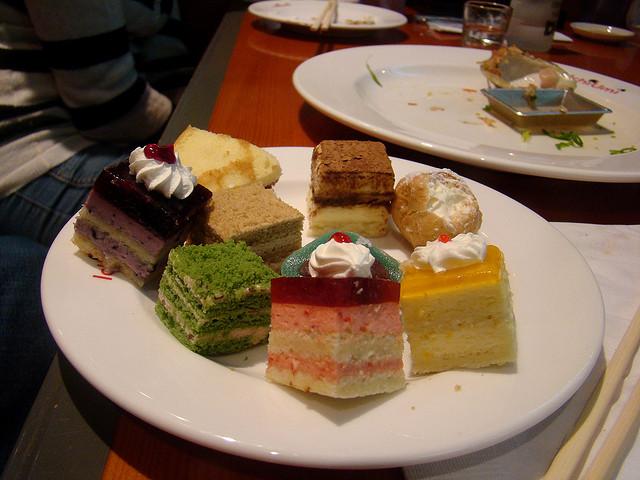How many cakes are present?
Keep it brief. 8. How many types of cakes are here?
Quick response, please. 8. What else in on the plate besides cakes?
Give a very brief answer. Creme puff. What is featured on the white plate?
Short answer required. Desserts. What type of pastry is shown?
Give a very brief answer. Cake. 